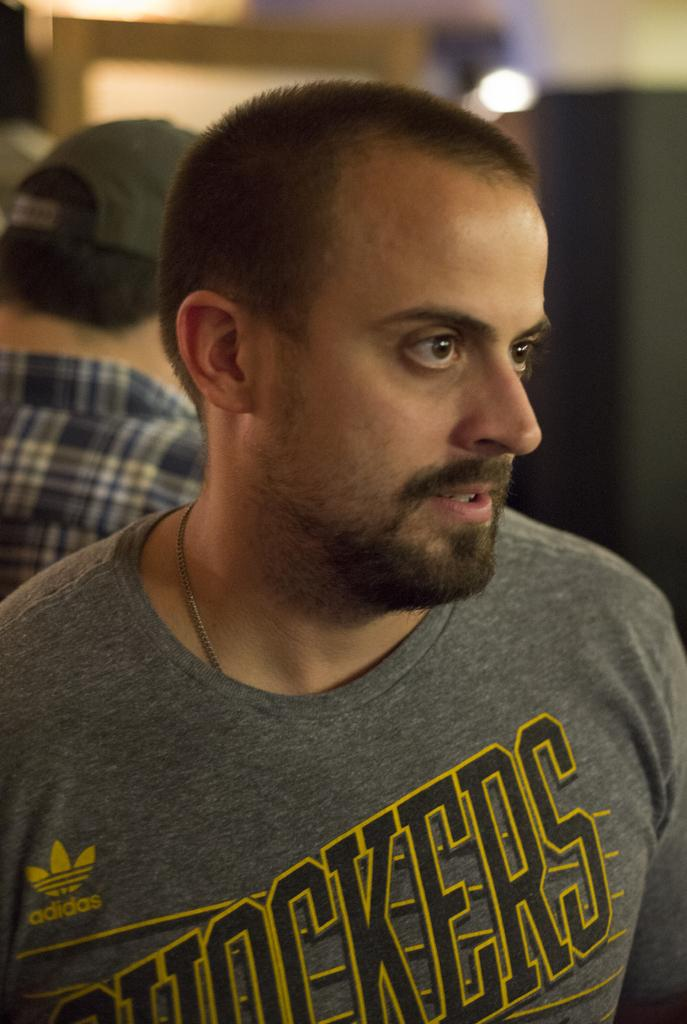Who is the main subject in the image? There is a man in the image. Can you describe any other person in the image? There is another person wearing a cap in the background. How would you describe the background of the image? The background appears blurry. What type of land can be seen in the image? There is no land visible in the image; it features a man and a person wearing a cap in a blurry background. 